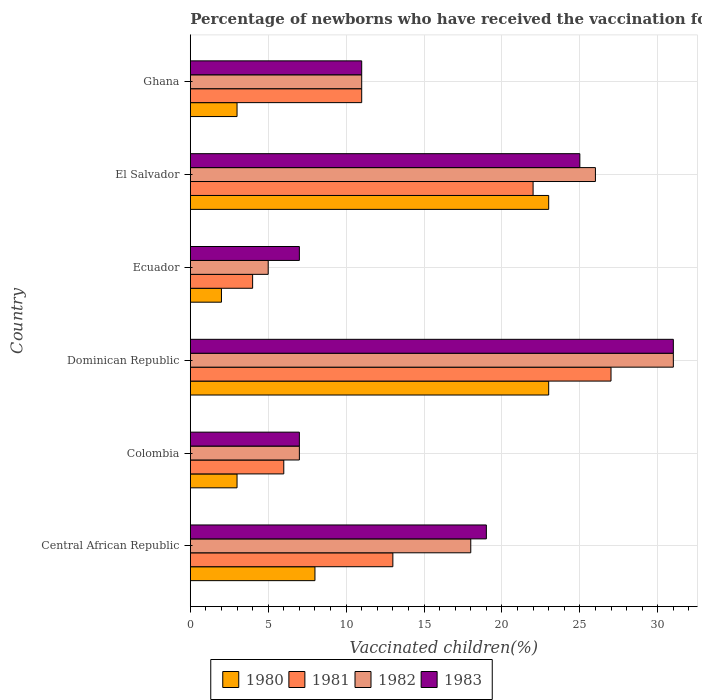Are the number of bars on each tick of the Y-axis equal?
Your answer should be very brief. Yes. How many bars are there on the 3rd tick from the top?
Keep it short and to the point. 4. In how many cases, is the number of bars for a given country not equal to the number of legend labels?
Your answer should be very brief. 0. What is the percentage of vaccinated children in 1982 in Ghana?
Make the answer very short. 11. In which country was the percentage of vaccinated children in 1983 maximum?
Make the answer very short. Dominican Republic. In which country was the percentage of vaccinated children in 1981 minimum?
Provide a short and direct response. Ecuador. What is the total percentage of vaccinated children in 1980 in the graph?
Provide a succinct answer. 62. What is the difference between the percentage of vaccinated children in 1980 in Dominican Republic and the percentage of vaccinated children in 1982 in Central African Republic?
Provide a succinct answer. 5. What is the average percentage of vaccinated children in 1981 per country?
Your answer should be very brief. 13.83. What is the difference between the percentage of vaccinated children in 1980 and percentage of vaccinated children in 1982 in Ghana?
Make the answer very short. -8. What is the ratio of the percentage of vaccinated children in 1981 in Central African Republic to that in Colombia?
Ensure brevity in your answer.  2.17. Is the sum of the percentage of vaccinated children in 1983 in Central African Republic and Ghana greater than the maximum percentage of vaccinated children in 1982 across all countries?
Your answer should be compact. No. Is it the case that in every country, the sum of the percentage of vaccinated children in 1982 and percentage of vaccinated children in 1980 is greater than the sum of percentage of vaccinated children in 1983 and percentage of vaccinated children in 1981?
Offer a very short reply. No. What does the 1st bar from the top in El Salvador represents?
Offer a terse response. 1983. What does the 3rd bar from the bottom in El Salvador represents?
Ensure brevity in your answer.  1982. Is it the case that in every country, the sum of the percentage of vaccinated children in 1981 and percentage of vaccinated children in 1983 is greater than the percentage of vaccinated children in 1982?
Offer a terse response. Yes. Are all the bars in the graph horizontal?
Your answer should be very brief. Yes. How many countries are there in the graph?
Give a very brief answer. 6. Are the values on the major ticks of X-axis written in scientific E-notation?
Provide a short and direct response. No. Where does the legend appear in the graph?
Keep it short and to the point. Bottom center. What is the title of the graph?
Offer a terse response. Percentage of newborns who have received the vaccination for tetanus. Does "1966" appear as one of the legend labels in the graph?
Give a very brief answer. No. What is the label or title of the X-axis?
Your response must be concise. Vaccinated children(%). What is the Vaccinated children(%) in 1981 in Central African Republic?
Provide a succinct answer. 13. What is the Vaccinated children(%) in 1982 in Central African Republic?
Keep it short and to the point. 18. What is the Vaccinated children(%) of 1981 in Colombia?
Your answer should be very brief. 6. What is the Vaccinated children(%) of 1982 in Colombia?
Give a very brief answer. 7. What is the Vaccinated children(%) of 1983 in Colombia?
Your response must be concise. 7. What is the Vaccinated children(%) in 1980 in Dominican Republic?
Your answer should be very brief. 23. What is the Vaccinated children(%) in 1982 in Ecuador?
Offer a very short reply. 5. What is the Vaccinated children(%) of 1981 in Ghana?
Provide a succinct answer. 11. Across all countries, what is the maximum Vaccinated children(%) of 1980?
Offer a terse response. 23. Across all countries, what is the maximum Vaccinated children(%) of 1983?
Ensure brevity in your answer.  31. Across all countries, what is the minimum Vaccinated children(%) in 1981?
Give a very brief answer. 4. Across all countries, what is the minimum Vaccinated children(%) in 1982?
Your answer should be very brief. 5. Across all countries, what is the minimum Vaccinated children(%) of 1983?
Offer a terse response. 7. What is the total Vaccinated children(%) in 1982 in the graph?
Your answer should be very brief. 98. What is the difference between the Vaccinated children(%) in 1982 in Central African Republic and that in Colombia?
Make the answer very short. 11. What is the difference between the Vaccinated children(%) in 1980 in Central African Republic and that in Dominican Republic?
Provide a short and direct response. -15. What is the difference between the Vaccinated children(%) in 1983 in Central African Republic and that in Dominican Republic?
Offer a terse response. -12. What is the difference between the Vaccinated children(%) in 1980 in Central African Republic and that in Ecuador?
Give a very brief answer. 6. What is the difference between the Vaccinated children(%) in 1981 in Central African Republic and that in Ecuador?
Offer a very short reply. 9. What is the difference between the Vaccinated children(%) of 1982 in Central African Republic and that in Ecuador?
Make the answer very short. 13. What is the difference between the Vaccinated children(%) of 1983 in Central African Republic and that in Ecuador?
Your answer should be very brief. 12. What is the difference between the Vaccinated children(%) of 1980 in Central African Republic and that in El Salvador?
Make the answer very short. -15. What is the difference between the Vaccinated children(%) in 1982 in Central African Republic and that in El Salvador?
Keep it short and to the point. -8. What is the difference between the Vaccinated children(%) of 1983 in Central African Republic and that in El Salvador?
Your answer should be very brief. -6. What is the difference between the Vaccinated children(%) in 1980 in Colombia and that in Ecuador?
Offer a terse response. 1. What is the difference between the Vaccinated children(%) in 1981 in Colombia and that in Ecuador?
Offer a very short reply. 2. What is the difference between the Vaccinated children(%) in 1980 in Colombia and that in El Salvador?
Provide a succinct answer. -20. What is the difference between the Vaccinated children(%) in 1982 in Colombia and that in El Salvador?
Keep it short and to the point. -19. What is the difference between the Vaccinated children(%) of 1982 in Colombia and that in Ghana?
Provide a succinct answer. -4. What is the difference between the Vaccinated children(%) of 1980 in Dominican Republic and that in Ecuador?
Provide a succinct answer. 21. What is the difference between the Vaccinated children(%) of 1983 in Dominican Republic and that in Ecuador?
Provide a succinct answer. 24. What is the difference between the Vaccinated children(%) in 1980 in Dominican Republic and that in El Salvador?
Provide a succinct answer. 0. What is the difference between the Vaccinated children(%) in 1981 in Dominican Republic and that in El Salvador?
Offer a terse response. 5. What is the difference between the Vaccinated children(%) in 1982 in Dominican Republic and that in El Salvador?
Offer a terse response. 5. What is the difference between the Vaccinated children(%) in 1980 in Ecuador and that in El Salvador?
Provide a short and direct response. -21. What is the difference between the Vaccinated children(%) of 1982 in Ecuador and that in El Salvador?
Offer a very short reply. -21. What is the difference between the Vaccinated children(%) in 1982 in Ecuador and that in Ghana?
Ensure brevity in your answer.  -6. What is the difference between the Vaccinated children(%) of 1980 in El Salvador and that in Ghana?
Offer a very short reply. 20. What is the difference between the Vaccinated children(%) in 1981 in El Salvador and that in Ghana?
Ensure brevity in your answer.  11. What is the difference between the Vaccinated children(%) of 1980 in Central African Republic and the Vaccinated children(%) of 1982 in Colombia?
Your answer should be very brief. 1. What is the difference between the Vaccinated children(%) in 1980 in Central African Republic and the Vaccinated children(%) in 1983 in Colombia?
Your response must be concise. 1. What is the difference between the Vaccinated children(%) in 1981 in Central African Republic and the Vaccinated children(%) in 1982 in Colombia?
Give a very brief answer. 6. What is the difference between the Vaccinated children(%) of 1982 in Central African Republic and the Vaccinated children(%) of 1983 in Colombia?
Ensure brevity in your answer.  11. What is the difference between the Vaccinated children(%) in 1980 in Central African Republic and the Vaccinated children(%) in 1981 in Dominican Republic?
Ensure brevity in your answer.  -19. What is the difference between the Vaccinated children(%) of 1980 in Central African Republic and the Vaccinated children(%) of 1982 in Dominican Republic?
Make the answer very short. -23. What is the difference between the Vaccinated children(%) in 1980 in Central African Republic and the Vaccinated children(%) in 1983 in Dominican Republic?
Offer a terse response. -23. What is the difference between the Vaccinated children(%) in 1981 in Central African Republic and the Vaccinated children(%) in 1982 in Dominican Republic?
Make the answer very short. -18. What is the difference between the Vaccinated children(%) in 1981 in Central African Republic and the Vaccinated children(%) in 1983 in Dominican Republic?
Make the answer very short. -18. What is the difference between the Vaccinated children(%) in 1982 in Central African Republic and the Vaccinated children(%) in 1983 in Dominican Republic?
Give a very brief answer. -13. What is the difference between the Vaccinated children(%) of 1980 in Central African Republic and the Vaccinated children(%) of 1983 in Ecuador?
Give a very brief answer. 1. What is the difference between the Vaccinated children(%) in 1981 in Central African Republic and the Vaccinated children(%) in 1982 in Ecuador?
Give a very brief answer. 8. What is the difference between the Vaccinated children(%) in 1981 in Central African Republic and the Vaccinated children(%) in 1983 in Ecuador?
Your answer should be very brief. 6. What is the difference between the Vaccinated children(%) of 1982 in Central African Republic and the Vaccinated children(%) of 1983 in Ecuador?
Make the answer very short. 11. What is the difference between the Vaccinated children(%) of 1980 in Central African Republic and the Vaccinated children(%) of 1981 in El Salvador?
Ensure brevity in your answer.  -14. What is the difference between the Vaccinated children(%) of 1980 in Central African Republic and the Vaccinated children(%) of 1982 in El Salvador?
Offer a very short reply. -18. What is the difference between the Vaccinated children(%) of 1980 in Central African Republic and the Vaccinated children(%) of 1983 in El Salvador?
Ensure brevity in your answer.  -17. What is the difference between the Vaccinated children(%) in 1981 in Central African Republic and the Vaccinated children(%) in 1982 in El Salvador?
Offer a terse response. -13. What is the difference between the Vaccinated children(%) of 1982 in Central African Republic and the Vaccinated children(%) of 1983 in El Salvador?
Provide a succinct answer. -7. What is the difference between the Vaccinated children(%) in 1980 in Central African Republic and the Vaccinated children(%) in 1981 in Ghana?
Your answer should be compact. -3. What is the difference between the Vaccinated children(%) in 1980 in Central African Republic and the Vaccinated children(%) in 1982 in Ghana?
Provide a short and direct response. -3. What is the difference between the Vaccinated children(%) in 1981 in Central African Republic and the Vaccinated children(%) in 1982 in Ghana?
Keep it short and to the point. 2. What is the difference between the Vaccinated children(%) in 1981 in Central African Republic and the Vaccinated children(%) in 1983 in Ghana?
Keep it short and to the point. 2. What is the difference between the Vaccinated children(%) in 1980 in Colombia and the Vaccinated children(%) in 1982 in Dominican Republic?
Your answer should be compact. -28. What is the difference between the Vaccinated children(%) in 1980 in Colombia and the Vaccinated children(%) in 1983 in Dominican Republic?
Provide a short and direct response. -28. What is the difference between the Vaccinated children(%) of 1980 in Colombia and the Vaccinated children(%) of 1981 in Ecuador?
Make the answer very short. -1. What is the difference between the Vaccinated children(%) in 1980 in Colombia and the Vaccinated children(%) in 1982 in Ecuador?
Your answer should be very brief. -2. What is the difference between the Vaccinated children(%) of 1980 in Colombia and the Vaccinated children(%) of 1983 in Ecuador?
Keep it short and to the point. -4. What is the difference between the Vaccinated children(%) in 1982 in Colombia and the Vaccinated children(%) in 1983 in Ecuador?
Make the answer very short. 0. What is the difference between the Vaccinated children(%) in 1980 in Colombia and the Vaccinated children(%) in 1981 in El Salvador?
Ensure brevity in your answer.  -19. What is the difference between the Vaccinated children(%) in 1981 in Colombia and the Vaccinated children(%) in 1983 in El Salvador?
Provide a short and direct response. -19. What is the difference between the Vaccinated children(%) of 1980 in Colombia and the Vaccinated children(%) of 1982 in Ghana?
Your answer should be compact. -8. What is the difference between the Vaccinated children(%) of 1980 in Colombia and the Vaccinated children(%) of 1983 in Ghana?
Offer a terse response. -8. What is the difference between the Vaccinated children(%) in 1980 in Dominican Republic and the Vaccinated children(%) in 1981 in Ecuador?
Offer a terse response. 19. What is the difference between the Vaccinated children(%) in 1981 in Dominican Republic and the Vaccinated children(%) in 1982 in Ecuador?
Your answer should be compact. 22. What is the difference between the Vaccinated children(%) of 1980 in Dominican Republic and the Vaccinated children(%) of 1981 in El Salvador?
Offer a very short reply. 1. What is the difference between the Vaccinated children(%) in 1980 in Dominican Republic and the Vaccinated children(%) in 1982 in El Salvador?
Your answer should be compact. -3. What is the difference between the Vaccinated children(%) in 1980 in Dominican Republic and the Vaccinated children(%) in 1983 in El Salvador?
Offer a terse response. -2. What is the difference between the Vaccinated children(%) of 1980 in Dominican Republic and the Vaccinated children(%) of 1982 in Ghana?
Give a very brief answer. 12. What is the difference between the Vaccinated children(%) of 1980 in Dominican Republic and the Vaccinated children(%) of 1983 in Ghana?
Provide a short and direct response. 12. What is the difference between the Vaccinated children(%) of 1981 in Dominican Republic and the Vaccinated children(%) of 1983 in Ghana?
Make the answer very short. 16. What is the difference between the Vaccinated children(%) of 1982 in Dominican Republic and the Vaccinated children(%) of 1983 in Ghana?
Provide a succinct answer. 20. What is the difference between the Vaccinated children(%) of 1980 in Ecuador and the Vaccinated children(%) of 1983 in El Salvador?
Your response must be concise. -23. What is the difference between the Vaccinated children(%) in 1980 in Ecuador and the Vaccinated children(%) in 1981 in Ghana?
Provide a succinct answer. -9. What is the difference between the Vaccinated children(%) in 1980 in Ecuador and the Vaccinated children(%) in 1982 in Ghana?
Provide a succinct answer. -9. What is the difference between the Vaccinated children(%) of 1981 in Ecuador and the Vaccinated children(%) of 1982 in Ghana?
Provide a succinct answer. -7. What is the difference between the Vaccinated children(%) in 1981 in Ecuador and the Vaccinated children(%) in 1983 in Ghana?
Make the answer very short. -7. What is the difference between the Vaccinated children(%) in 1980 in El Salvador and the Vaccinated children(%) in 1981 in Ghana?
Keep it short and to the point. 12. What is the difference between the Vaccinated children(%) of 1980 in El Salvador and the Vaccinated children(%) of 1982 in Ghana?
Offer a very short reply. 12. What is the difference between the Vaccinated children(%) in 1982 in El Salvador and the Vaccinated children(%) in 1983 in Ghana?
Your response must be concise. 15. What is the average Vaccinated children(%) in 1980 per country?
Your answer should be compact. 10.33. What is the average Vaccinated children(%) of 1981 per country?
Provide a succinct answer. 13.83. What is the average Vaccinated children(%) in 1982 per country?
Your answer should be very brief. 16.33. What is the average Vaccinated children(%) of 1983 per country?
Your answer should be very brief. 16.67. What is the difference between the Vaccinated children(%) of 1980 and Vaccinated children(%) of 1982 in Central African Republic?
Ensure brevity in your answer.  -10. What is the difference between the Vaccinated children(%) in 1980 and Vaccinated children(%) in 1983 in Central African Republic?
Provide a succinct answer. -11. What is the difference between the Vaccinated children(%) in 1980 and Vaccinated children(%) in 1982 in Colombia?
Offer a very short reply. -4. What is the difference between the Vaccinated children(%) of 1980 and Vaccinated children(%) of 1983 in Colombia?
Make the answer very short. -4. What is the difference between the Vaccinated children(%) of 1980 and Vaccinated children(%) of 1981 in Dominican Republic?
Give a very brief answer. -4. What is the difference between the Vaccinated children(%) of 1980 and Vaccinated children(%) of 1983 in Dominican Republic?
Your response must be concise. -8. What is the difference between the Vaccinated children(%) of 1981 and Vaccinated children(%) of 1982 in Dominican Republic?
Provide a succinct answer. -4. What is the difference between the Vaccinated children(%) in 1980 and Vaccinated children(%) in 1981 in Ecuador?
Your response must be concise. -2. What is the difference between the Vaccinated children(%) of 1981 and Vaccinated children(%) of 1982 in Ecuador?
Make the answer very short. -1. What is the difference between the Vaccinated children(%) in 1981 and Vaccinated children(%) in 1983 in Ecuador?
Offer a very short reply. -3. What is the difference between the Vaccinated children(%) of 1982 and Vaccinated children(%) of 1983 in Ecuador?
Your answer should be compact. -2. What is the difference between the Vaccinated children(%) of 1980 and Vaccinated children(%) of 1982 in El Salvador?
Your response must be concise. -3. What is the difference between the Vaccinated children(%) of 1980 and Vaccinated children(%) of 1981 in Ghana?
Provide a succinct answer. -8. What is the difference between the Vaccinated children(%) of 1981 and Vaccinated children(%) of 1982 in Ghana?
Your response must be concise. 0. What is the difference between the Vaccinated children(%) of 1981 and Vaccinated children(%) of 1983 in Ghana?
Ensure brevity in your answer.  0. What is the difference between the Vaccinated children(%) of 1982 and Vaccinated children(%) of 1983 in Ghana?
Provide a succinct answer. 0. What is the ratio of the Vaccinated children(%) in 1980 in Central African Republic to that in Colombia?
Make the answer very short. 2.67. What is the ratio of the Vaccinated children(%) of 1981 in Central African Republic to that in Colombia?
Make the answer very short. 2.17. What is the ratio of the Vaccinated children(%) of 1982 in Central African Republic to that in Colombia?
Ensure brevity in your answer.  2.57. What is the ratio of the Vaccinated children(%) of 1983 in Central African Republic to that in Colombia?
Your answer should be very brief. 2.71. What is the ratio of the Vaccinated children(%) of 1980 in Central African Republic to that in Dominican Republic?
Provide a succinct answer. 0.35. What is the ratio of the Vaccinated children(%) of 1981 in Central African Republic to that in Dominican Republic?
Ensure brevity in your answer.  0.48. What is the ratio of the Vaccinated children(%) of 1982 in Central African Republic to that in Dominican Republic?
Make the answer very short. 0.58. What is the ratio of the Vaccinated children(%) of 1983 in Central African Republic to that in Dominican Republic?
Offer a terse response. 0.61. What is the ratio of the Vaccinated children(%) in 1980 in Central African Republic to that in Ecuador?
Make the answer very short. 4. What is the ratio of the Vaccinated children(%) in 1981 in Central African Republic to that in Ecuador?
Give a very brief answer. 3.25. What is the ratio of the Vaccinated children(%) in 1983 in Central African Republic to that in Ecuador?
Make the answer very short. 2.71. What is the ratio of the Vaccinated children(%) of 1980 in Central African Republic to that in El Salvador?
Offer a terse response. 0.35. What is the ratio of the Vaccinated children(%) of 1981 in Central African Republic to that in El Salvador?
Provide a succinct answer. 0.59. What is the ratio of the Vaccinated children(%) of 1982 in Central African Republic to that in El Salvador?
Provide a succinct answer. 0.69. What is the ratio of the Vaccinated children(%) in 1983 in Central African Republic to that in El Salvador?
Your answer should be compact. 0.76. What is the ratio of the Vaccinated children(%) in 1980 in Central African Republic to that in Ghana?
Your answer should be compact. 2.67. What is the ratio of the Vaccinated children(%) of 1981 in Central African Republic to that in Ghana?
Your response must be concise. 1.18. What is the ratio of the Vaccinated children(%) of 1982 in Central African Republic to that in Ghana?
Provide a succinct answer. 1.64. What is the ratio of the Vaccinated children(%) of 1983 in Central African Republic to that in Ghana?
Keep it short and to the point. 1.73. What is the ratio of the Vaccinated children(%) in 1980 in Colombia to that in Dominican Republic?
Your response must be concise. 0.13. What is the ratio of the Vaccinated children(%) in 1981 in Colombia to that in Dominican Republic?
Keep it short and to the point. 0.22. What is the ratio of the Vaccinated children(%) of 1982 in Colombia to that in Dominican Republic?
Provide a short and direct response. 0.23. What is the ratio of the Vaccinated children(%) in 1983 in Colombia to that in Dominican Republic?
Provide a short and direct response. 0.23. What is the ratio of the Vaccinated children(%) in 1980 in Colombia to that in Ecuador?
Your response must be concise. 1.5. What is the ratio of the Vaccinated children(%) in 1982 in Colombia to that in Ecuador?
Give a very brief answer. 1.4. What is the ratio of the Vaccinated children(%) of 1980 in Colombia to that in El Salvador?
Make the answer very short. 0.13. What is the ratio of the Vaccinated children(%) in 1981 in Colombia to that in El Salvador?
Your answer should be compact. 0.27. What is the ratio of the Vaccinated children(%) in 1982 in Colombia to that in El Salvador?
Provide a short and direct response. 0.27. What is the ratio of the Vaccinated children(%) in 1983 in Colombia to that in El Salvador?
Provide a short and direct response. 0.28. What is the ratio of the Vaccinated children(%) in 1981 in Colombia to that in Ghana?
Your answer should be very brief. 0.55. What is the ratio of the Vaccinated children(%) in 1982 in Colombia to that in Ghana?
Give a very brief answer. 0.64. What is the ratio of the Vaccinated children(%) of 1983 in Colombia to that in Ghana?
Ensure brevity in your answer.  0.64. What is the ratio of the Vaccinated children(%) in 1981 in Dominican Republic to that in Ecuador?
Your response must be concise. 6.75. What is the ratio of the Vaccinated children(%) of 1982 in Dominican Republic to that in Ecuador?
Provide a succinct answer. 6.2. What is the ratio of the Vaccinated children(%) in 1983 in Dominican Republic to that in Ecuador?
Ensure brevity in your answer.  4.43. What is the ratio of the Vaccinated children(%) in 1980 in Dominican Republic to that in El Salvador?
Offer a very short reply. 1. What is the ratio of the Vaccinated children(%) in 1981 in Dominican Republic to that in El Salvador?
Your response must be concise. 1.23. What is the ratio of the Vaccinated children(%) of 1982 in Dominican Republic to that in El Salvador?
Make the answer very short. 1.19. What is the ratio of the Vaccinated children(%) in 1983 in Dominican Republic to that in El Salvador?
Your answer should be compact. 1.24. What is the ratio of the Vaccinated children(%) in 1980 in Dominican Republic to that in Ghana?
Give a very brief answer. 7.67. What is the ratio of the Vaccinated children(%) in 1981 in Dominican Republic to that in Ghana?
Make the answer very short. 2.45. What is the ratio of the Vaccinated children(%) in 1982 in Dominican Republic to that in Ghana?
Give a very brief answer. 2.82. What is the ratio of the Vaccinated children(%) of 1983 in Dominican Republic to that in Ghana?
Give a very brief answer. 2.82. What is the ratio of the Vaccinated children(%) in 1980 in Ecuador to that in El Salvador?
Ensure brevity in your answer.  0.09. What is the ratio of the Vaccinated children(%) of 1981 in Ecuador to that in El Salvador?
Keep it short and to the point. 0.18. What is the ratio of the Vaccinated children(%) of 1982 in Ecuador to that in El Salvador?
Provide a succinct answer. 0.19. What is the ratio of the Vaccinated children(%) in 1983 in Ecuador to that in El Salvador?
Your response must be concise. 0.28. What is the ratio of the Vaccinated children(%) in 1981 in Ecuador to that in Ghana?
Your answer should be very brief. 0.36. What is the ratio of the Vaccinated children(%) of 1982 in Ecuador to that in Ghana?
Provide a succinct answer. 0.45. What is the ratio of the Vaccinated children(%) of 1983 in Ecuador to that in Ghana?
Offer a very short reply. 0.64. What is the ratio of the Vaccinated children(%) in 1980 in El Salvador to that in Ghana?
Keep it short and to the point. 7.67. What is the ratio of the Vaccinated children(%) in 1981 in El Salvador to that in Ghana?
Provide a short and direct response. 2. What is the ratio of the Vaccinated children(%) in 1982 in El Salvador to that in Ghana?
Provide a short and direct response. 2.36. What is the ratio of the Vaccinated children(%) in 1983 in El Salvador to that in Ghana?
Give a very brief answer. 2.27. What is the difference between the highest and the second highest Vaccinated children(%) in 1980?
Provide a short and direct response. 0. What is the difference between the highest and the second highest Vaccinated children(%) of 1981?
Make the answer very short. 5. What is the difference between the highest and the lowest Vaccinated children(%) of 1980?
Offer a very short reply. 21. What is the difference between the highest and the lowest Vaccinated children(%) of 1982?
Give a very brief answer. 26. What is the difference between the highest and the lowest Vaccinated children(%) in 1983?
Your response must be concise. 24. 